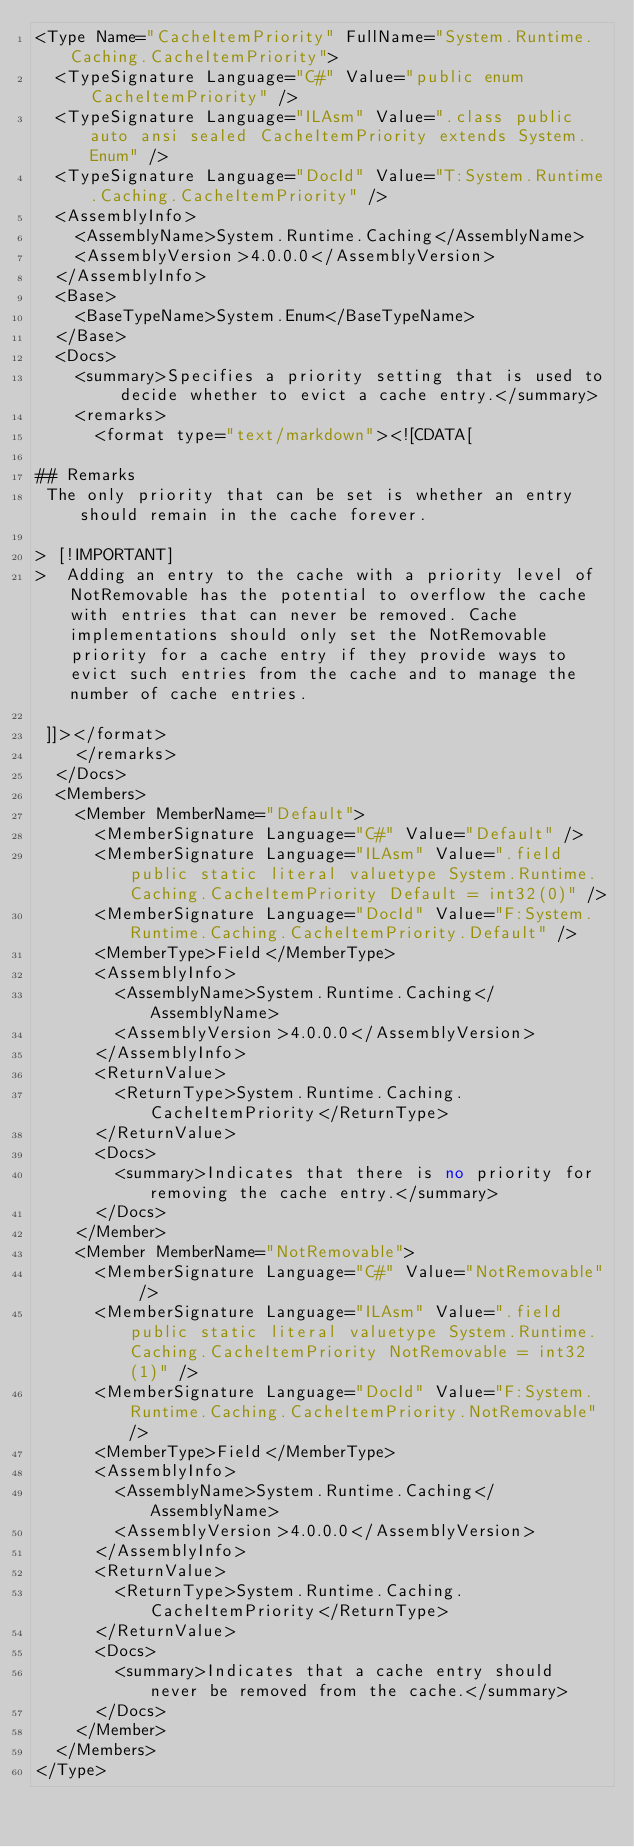Convert code to text. <code><loc_0><loc_0><loc_500><loc_500><_XML_><Type Name="CacheItemPriority" FullName="System.Runtime.Caching.CacheItemPriority">
  <TypeSignature Language="C#" Value="public enum CacheItemPriority" />
  <TypeSignature Language="ILAsm" Value=".class public auto ansi sealed CacheItemPriority extends System.Enum" />
  <TypeSignature Language="DocId" Value="T:System.Runtime.Caching.CacheItemPriority" />
  <AssemblyInfo>
    <AssemblyName>System.Runtime.Caching</AssemblyName>
    <AssemblyVersion>4.0.0.0</AssemblyVersion>
  </AssemblyInfo>
  <Base>
    <BaseTypeName>System.Enum</BaseTypeName>
  </Base>
  <Docs>
    <summary>Specifies a priority setting that is used to decide whether to evict a cache entry.</summary>
    <remarks>
      <format type="text/markdown"><![CDATA[  
  
## Remarks  
 The only priority that can be set is whether an entry should remain in the cache forever.  
  
> [!IMPORTANT]
>  Adding an entry to the cache with a priority level of NotRemovable has the potential to overflow the cache with entries that can never be removed. Cache implementations should only set the NotRemovable priority for a cache entry if they provide ways to evict such entries from the cache and to manage the number of cache entries.  
  
 ]]></format>
    </remarks>
  </Docs>
  <Members>
    <Member MemberName="Default">
      <MemberSignature Language="C#" Value="Default" />
      <MemberSignature Language="ILAsm" Value=".field public static literal valuetype System.Runtime.Caching.CacheItemPriority Default = int32(0)" />
      <MemberSignature Language="DocId" Value="F:System.Runtime.Caching.CacheItemPriority.Default" />
      <MemberType>Field</MemberType>
      <AssemblyInfo>
        <AssemblyName>System.Runtime.Caching</AssemblyName>
        <AssemblyVersion>4.0.0.0</AssemblyVersion>
      </AssemblyInfo>
      <ReturnValue>
        <ReturnType>System.Runtime.Caching.CacheItemPriority</ReturnType>
      </ReturnValue>
      <Docs>
        <summary>Indicates that there is no priority for removing the cache entry.</summary>
      </Docs>
    </Member>
    <Member MemberName="NotRemovable">
      <MemberSignature Language="C#" Value="NotRemovable" />
      <MemberSignature Language="ILAsm" Value=".field public static literal valuetype System.Runtime.Caching.CacheItemPriority NotRemovable = int32(1)" />
      <MemberSignature Language="DocId" Value="F:System.Runtime.Caching.CacheItemPriority.NotRemovable" />
      <MemberType>Field</MemberType>
      <AssemblyInfo>
        <AssemblyName>System.Runtime.Caching</AssemblyName>
        <AssemblyVersion>4.0.0.0</AssemblyVersion>
      </AssemblyInfo>
      <ReturnValue>
        <ReturnType>System.Runtime.Caching.CacheItemPriority</ReturnType>
      </ReturnValue>
      <Docs>
        <summary>Indicates that a cache entry should never be removed from the cache.</summary>
      </Docs>
    </Member>
  </Members>
</Type>
</code> 